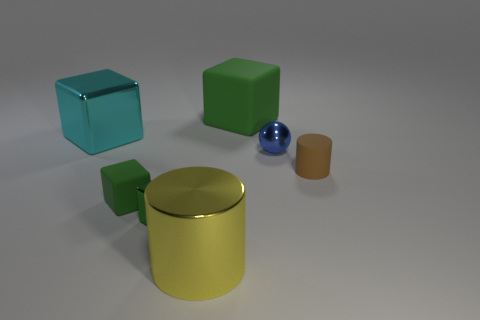There is a tiny object that is the same color as the small rubber cube; what is its shape?
Your answer should be very brief. Cube. There is a cyan metallic object that is the same size as the yellow metal cylinder; what shape is it?
Make the answer very short. Cube. The cyan thing that is the same shape as the green metallic object is what size?
Offer a terse response. Large. Are there an equal number of metal cylinders in front of the tiny cylinder and matte objects left of the large green block?
Provide a succinct answer. Yes. What number of other objects are the same material as the yellow cylinder?
Keep it short and to the point. 3. Is the number of yellow objects behind the large cyan cube the same as the number of red matte things?
Make the answer very short. Yes. There is a brown cylinder; is its size the same as the cylinder on the left side of the big green cube?
Provide a short and direct response. No. The matte thing on the left side of the big green matte thing has what shape?
Your answer should be very brief. Cube. Are there any other things that have the same shape as the blue object?
Your answer should be compact. No. Are any small purple rubber blocks visible?
Offer a terse response. No. 